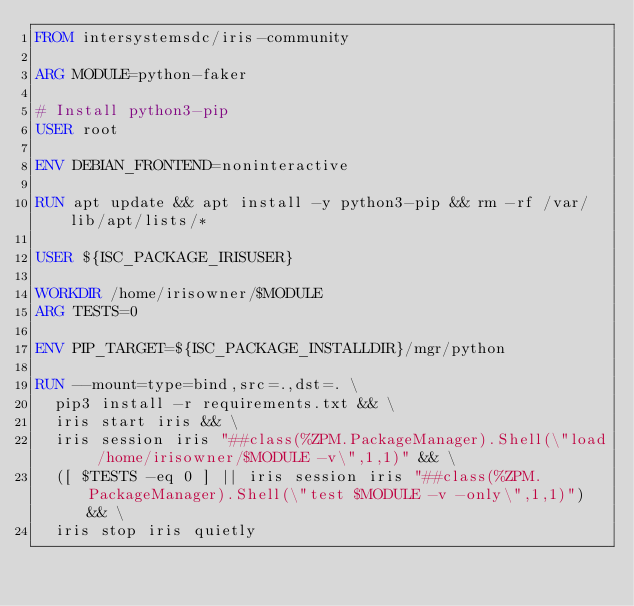Convert code to text. <code><loc_0><loc_0><loc_500><loc_500><_Dockerfile_>FROM intersystemsdc/iris-community

ARG MODULE=python-faker

# Install python3-pip
USER root

ENV DEBIAN_FRONTEND=noninteractive

RUN apt update && apt install -y python3-pip && rm -rf /var/lib/apt/lists/*

USER ${ISC_PACKAGE_IRISUSER}

WORKDIR /home/irisowner/$MODULE
ARG TESTS=0

ENV PIP_TARGET=${ISC_PACKAGE_INSTALLDIR}/mgr/python

RUN --mount=type=bind,src=.,dst=. \
  pip3 install -r requirements.txt && \
  iris start iris && \
  iris session iris "##class(%ZPM.PackageManager).Shell(\"load /home/irisowner/$MODULE -v\",1,1)" && \
  ([ $TESTS -eq 0 ] || iris session iris "##class(%ZPM.PackageManager).Shell(\"test $MODULE -v -only\",1,1)") && \
  iris stop iris quietly
</code> 